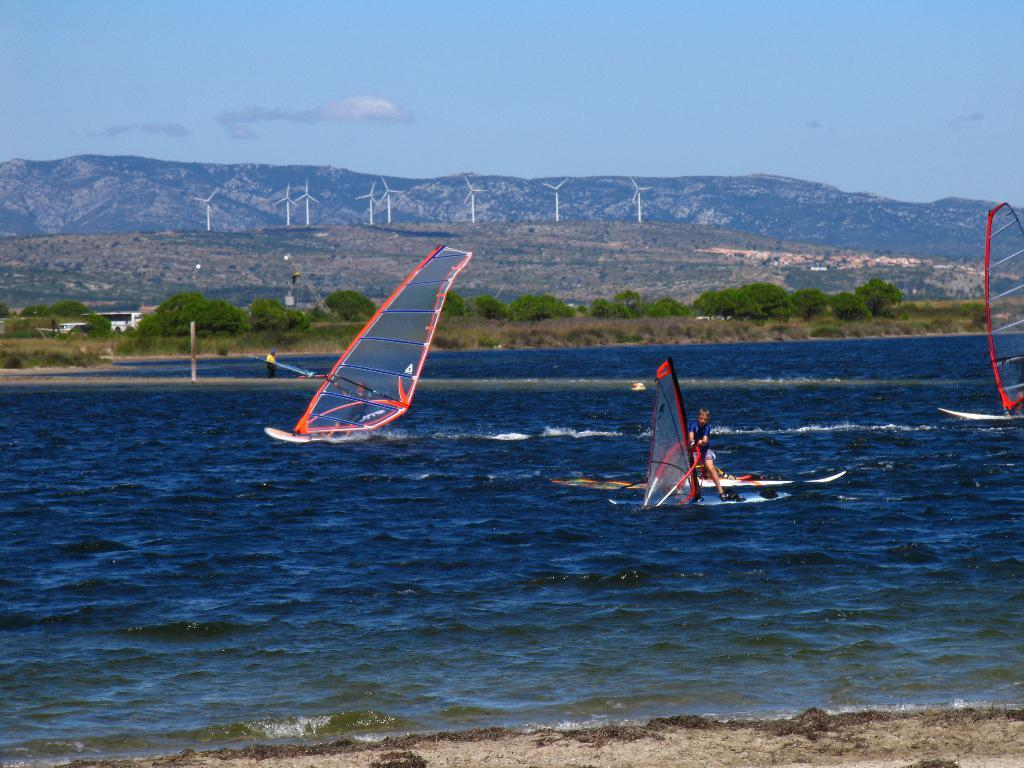What are the people doing in the boats? The people are in the boats, and they are holding something. Where are the boats located? The boats are on the water surface. What other structures can be seen in the image? There are windmills visible in the image. What type of natural features can be seen in the image? There are mountains and trees in the image. What part of the environment is visible in the image? The sky is visible in the image. What type of ring can be seen on the robin's beak in the image? There is no robin or ring present in the image. What is the surprise element in the image? There is no surprise element mentioned in the provided facts; the image simply depicts people in boats, windmills, mountains, trees, and the sky. 